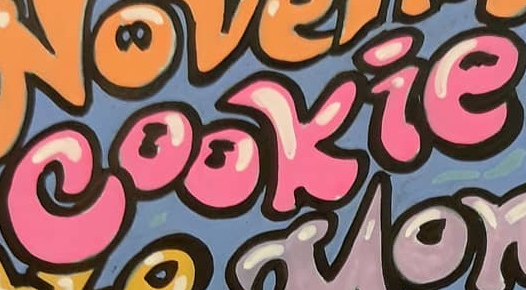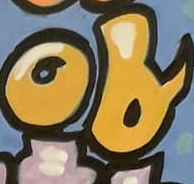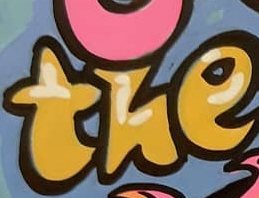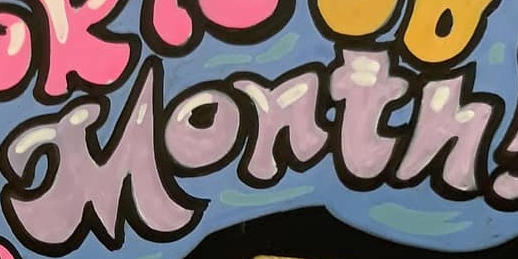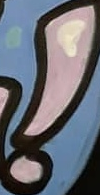What text is displayed in these images sequentially, separated by a semicolon? cookie; of; the; Month; ! 